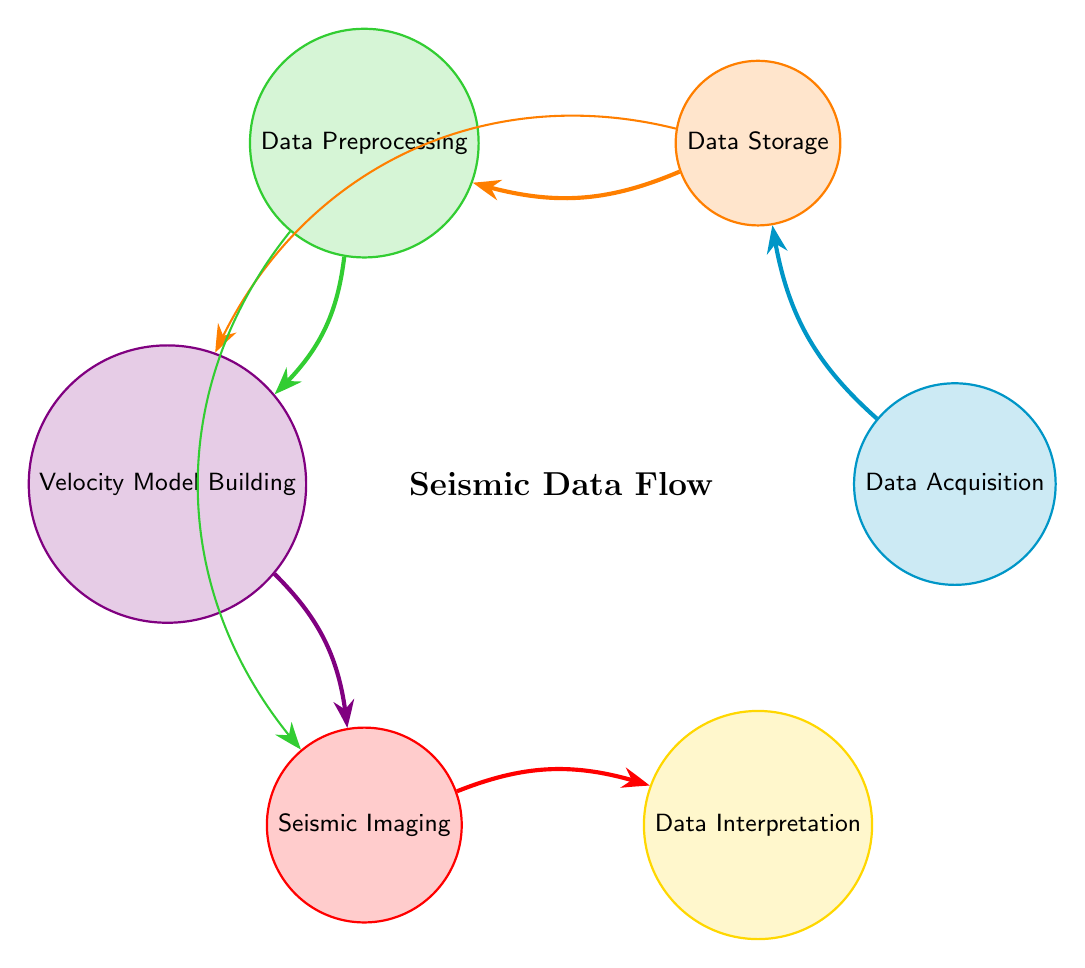What is the first stage in the seismic imaging process? The first stage in the diagram is labeled "Data Acquisition," indicating that data is gathered before any other processing steps occur.
Answer: Data Acquisition How many total nodes are represented in this chord diagram? The diagram includes six distinct nodes: Data Acquisition, Data Storage, Data Preprocessing, Velocity Model Building, Seismic Imaging, and Data Interpretation.
Answer: 6 Which two stages directly connect to "Data Storage"? "Data Acquisition" connects to "Data Storage," and "Velocity Model Building" also has a direct connection to "Data Storage," as indicated by the links in the diagram.
Answer: Data Acquisition and Velocity Model Building What is the linking value between "Data Preprocessing" and "Seismic Imaging"? The diagram shows a linking value of 0.5 between "Data Preprocessing" and "Seismic Imaging," implying a partial flow of data or influence from preprocessing to imaging.
Answer: 0.5 Which stage has the final output in the seismic imaging process? The final output stage according to the diagram is "Data Interpretation," as it follows "Seismic Imaging" in the flow of data.
Answer: Data Interpretation What are the two processes that have an incoming connection from "Data Storage"? The processes that receive incoming connections from "Data Storage" are "Data Preprocessing" and "Velocity Model Building," as shown by the directed links in the diagram.
Answer: Data Preprocessing and Velocity Model Building Which stage has connections coming from both "Data Preprocessing" and "Data Storage"? "Velocity Model Building" is the stage that has incoming connections from both "Data Preprocessing" and "Data Storage," indicating it utilizes data from these two stages.
Answer: Velocity Model Building Which stage involves the transformation of seismic data into images? The stage that transforms seismic data into images is "Seismic Imaging," as indicated by its definition and the flow of data leading into it from previous stages.
Answer: Seismic Imaging 